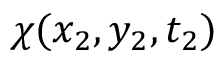<formula> <loc_0><loc_0><loc_500><loc_500>\chi ( x _ { 2 } , y _ { 2 } , t _ { 2 } )</formula> 